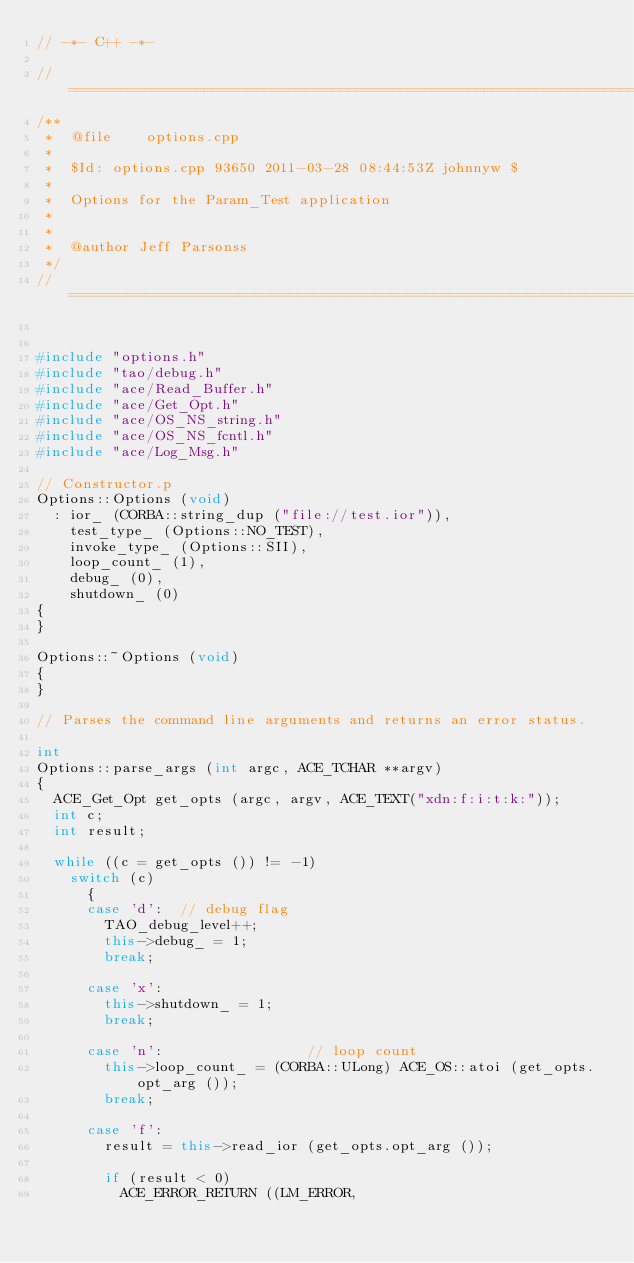Convert code to text. <code><loc_0><loc_0><loc_500><loc_500><_C++_>// -*- C++ -*-

//=============================================================================
/**
 *  @file    options.cpp
 *
 *  $Id: options.cpp 93650 2011-03-28 08:44:53Z johnnyw $
 *
 *  Options for the Param_Test application
 *
 *
 *  @author Jeff Parsonss
 */
//=============================================================================


#include "options.h"
#include "tao/debug.h"
#include "ace/Read_Buffer.h"
#include "ace/Get_Opt.h"
#include "ace/OS_NS_string.h"
#include "ace/OS_NS_fcntl.h"
#include "ace/Log_Msg.h"

// Constructor.p
Options::Options (void)
  : ior_ (CORBA::string_dup ("file://test.ior")),
    test_type_ (Options::NO_TEST),
    invoke_type_ (Options::SII),
    loop_count_ (1),
    debug_ (0),
    shutdown_ (0)
{
}

Options::~Options (void)
{
}

// Parses the command line arguments and returns an error status.

int
Options::parse_args (int argc, ACE_TCHAR **argv)
{
  ACE_Get_Opt get_opts (argc, argv, ACE_TEXT("xdn:f:i:t:k:"));
  int c;
  int result;

  while ((c = get_opts ()) != -1)
    switch (c)
      {
      case 'd':  // debug flag
        TAO_debug_level++;
        this->debug_ = 1;
        break;

      case 'x':
        this->shutdown_ = 1;
        break;

      case 'n':                 // loop count
        this->loop_count_ = (CORBA::ULong) ACE_OS::atoi (get_opts.opt_arg ());
        break;

      case 'f':
        result = this->read_ior (get_opts.opt_arg ());

        if (result < 0)
          ACE_ERROR_RETURN ((LM_ERROR,</code> 